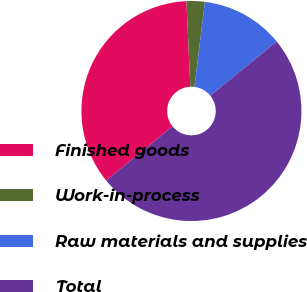<chart> <loc_0><loc_0><loc_500><loc_500><pie_chart><fcel>Finished goods<fcel>Work-in-process<fcel>Raw materials and supplies<fcel>Total<nl><fcel>35.15%<fcel>2.68%<fcel>12.16%<fcel>50.0%<nl></chart> 